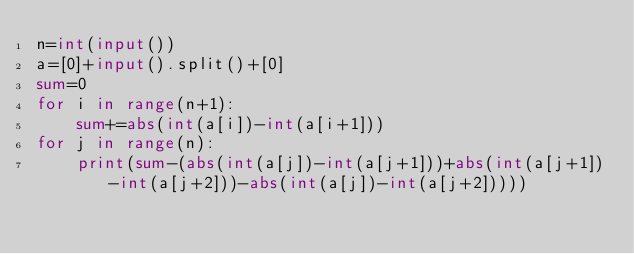<code> <loc_0><loc_0><loc_500><loc_500><_Python_>n=int(input())
a=[0]+input().split()+[0]
sum=0
for i in range(n+1):
    sum+=abs(int(a[i])-int(a[i+1]))
for j in range(n):
    print(sum-(abs(int(a[j])-int(a[j+1]))+abs(int(a[j+1])-int(a[j+2]))-abs(int(a[j])-int(a[j+2]))))</code> 